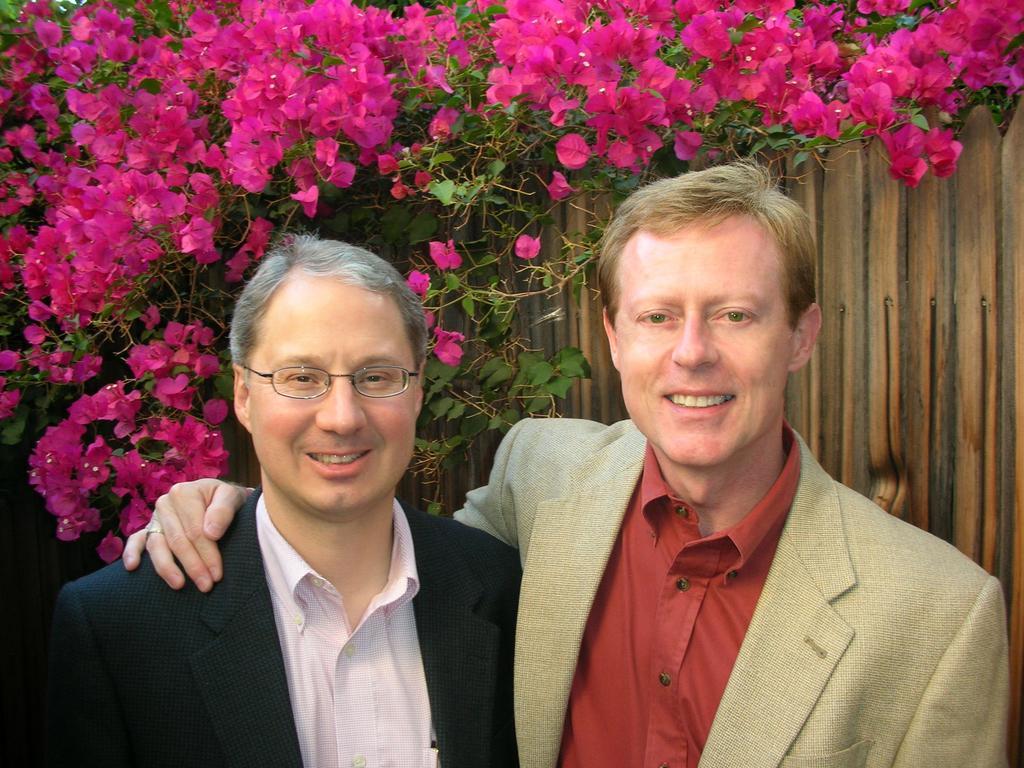Can you describe this image briefly? In this picture we can see two men standing here, they wore suits, in the background we can see flowers and leaves, we can see a wooden fence here. 